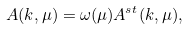Convert formula to latex. <formula><loc_0><loc_0><loc_500><loc_500>A ( k , \mu ) = \omega ( \mu ) A ^ { s t } ( k , \mu ) ,</formula> 